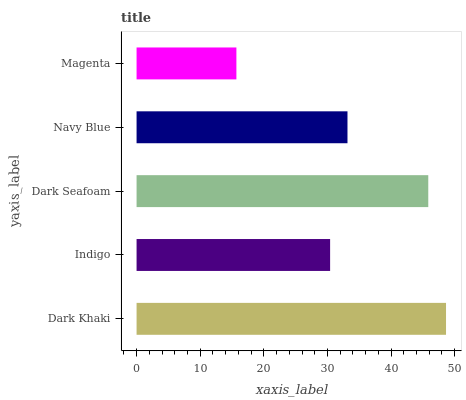Is Magenta the minimum?
Answer yes or no. Yes. Is Dark Khaki the maximum?
Answer yes or no. Yes. Is Indigo the minimum?
Answer yes or no. No. Is Indigo the maximum?
Answer yes or no. No. Is Dark Khaki greater than Indigo?
Answer yes or no. Yes. Is Indigo less than Dark Khaki?
Answer yes or no. Yes. Is Indigo greater than Dark Khaki?
Answer yes or no. No. Is Dark Khaki less than Indigo?
Answer yes or no. No. Is Navy Blue the high median?
Answer yes or no. Yes. Is Navy Blue the low median?
Answer yes or no. Yes. Is Dark Seafoam the high median?
Answer yes or no. No. Is Magenta the low median?
Answer yes or no. No. 